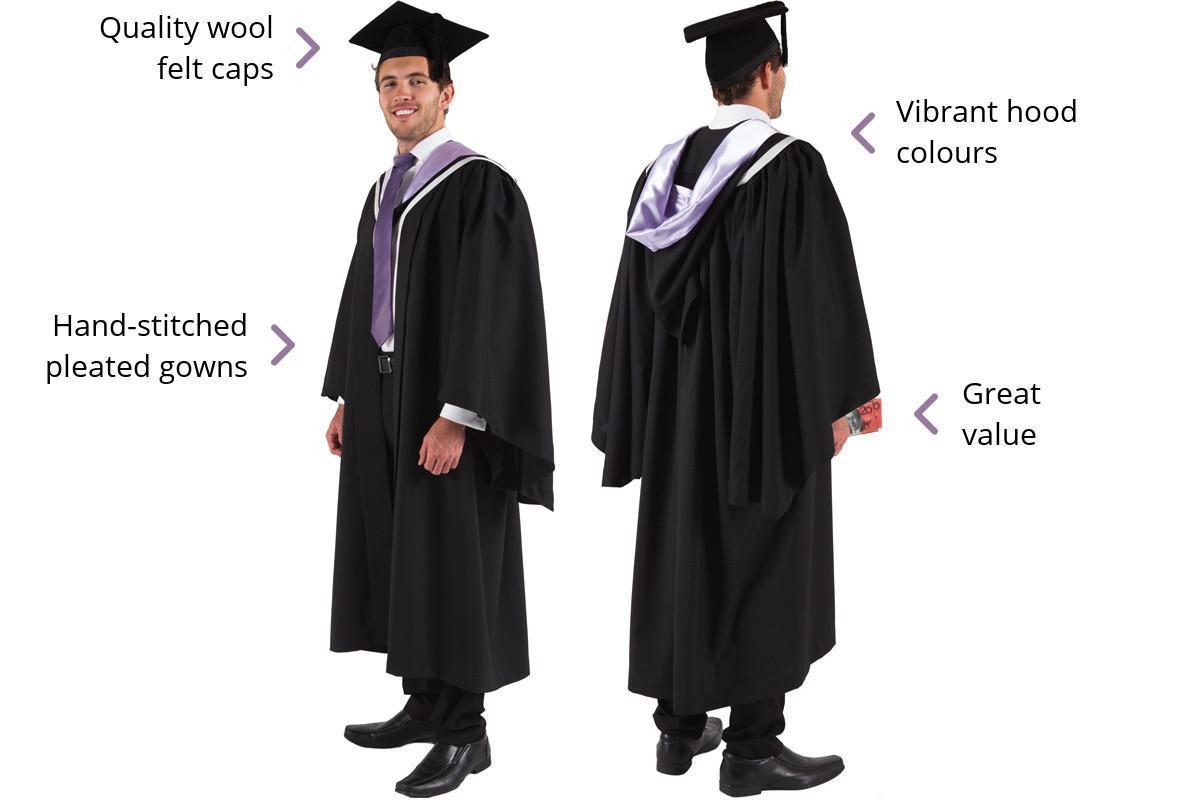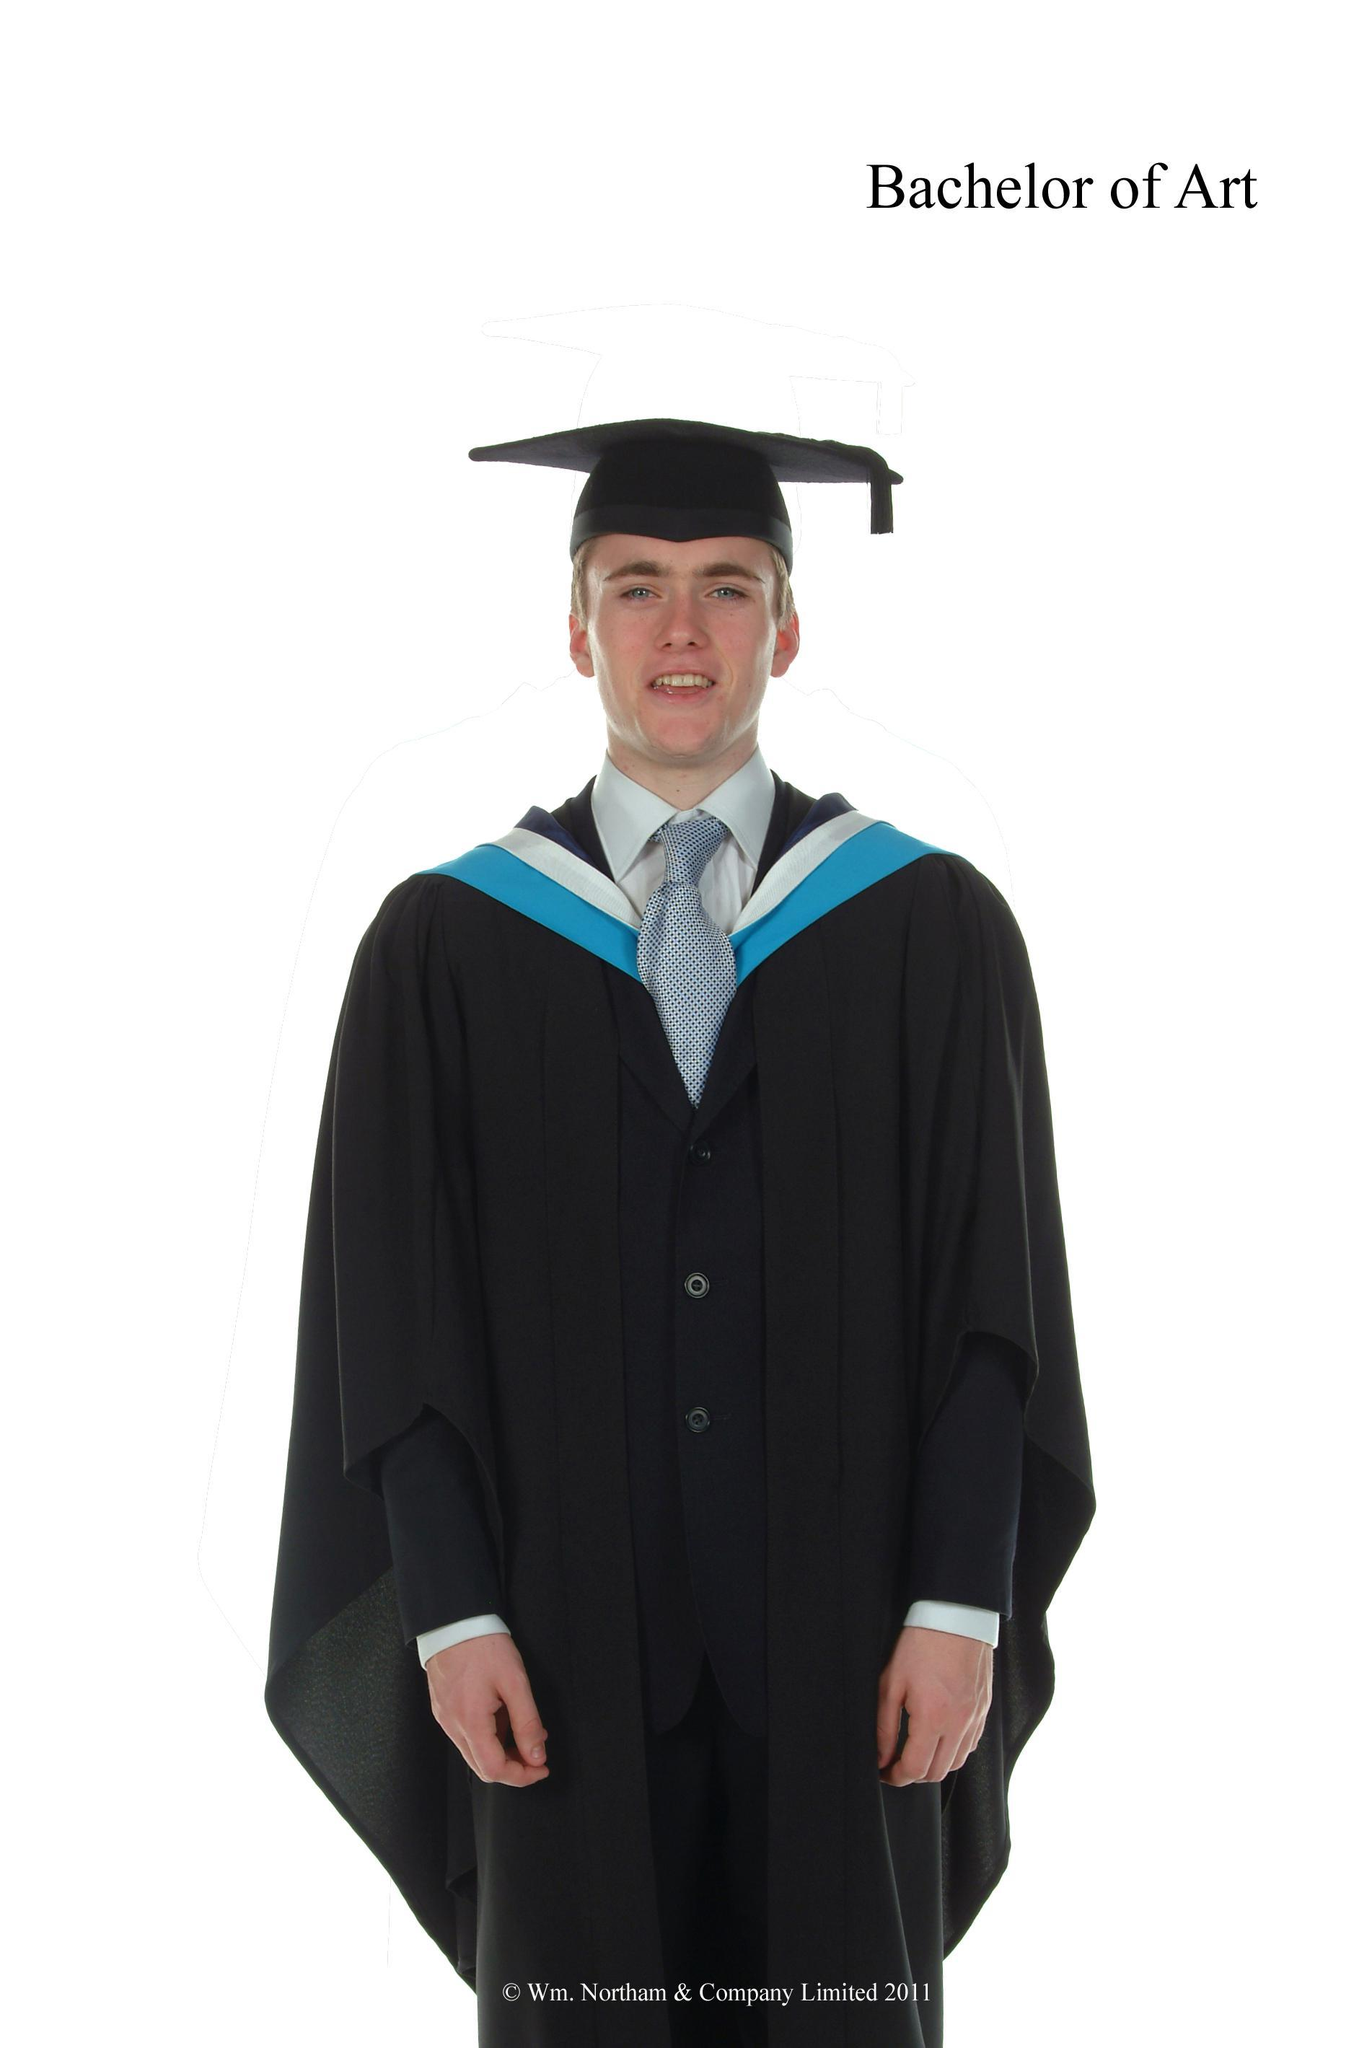The first image is the image on the left, the second image is the image on the right. Examine the images to the left and right. Is the description "The man on the left has a yellow tassel." accurate? Answer yes or no. No. The first image is the image on the left, the second image is the image on the right. Evaluate the accuracy of this statement regarding the images: "An image shows male modeling back and front views of graduation garb.". Is it true? Answer yes or no. Yes. The first image is the image on the left, the second image is the image on the right. For the images displayed, is the sentence "there is exactly one person in the image on the left" factually correct? Answer yes or no. No. 